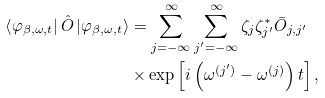<formula> <loc_0><loc_0><loc_500><loc_500>\left \langle \varphi _ { \beta , \omega , t } \right | \hat { O } \left | \varphi _ { \beta , \omega , t } \right \rangle & = \sum _ { j = - \infty } ^ { \infty } \sum _ { j ^ { \prime } = - \infty } ^ { \infty } \zeta _ { j } \zeta _ { j ^ { \prime } } ^ { \ast } \bar { O } _ { j , j ^ { \prime } } \\ & \times \exp \left [ i \left ( \omega ^ { ( j ^ { \prime } ) } - \omega ^ { ( j ) } \right ) t \right ] ,</formula> 